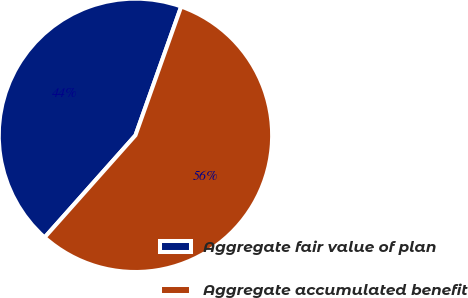<chart> <loc_0><loc_0><loc_500><loc_500><pie_chart><fcel>Aggregate fair value of plan<fcel>Aggregate accumulated benefit<nl><fcel>43.86%<fcel>56.14%<nl></chart> 